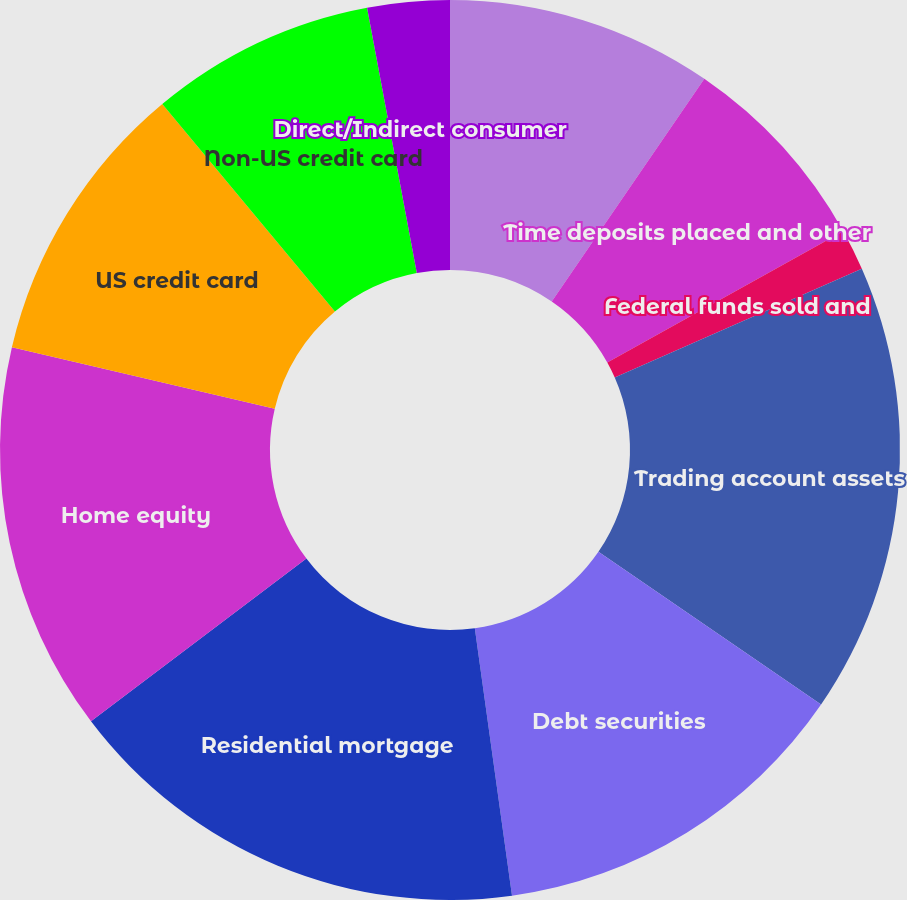Convert chart to OTSL. <chart><loc_0><loc_0><loc_500><loc_500><pie_chart><fcel>Interest-bearing deposits with<fcel>Time deposits placed and other<fcel>Federal funds sold and<fcel>Trading account assets<fcel>Debt securities<fcel>Residential mortgage<fcel>Home equity<fcel>US credit card<fcel>Non-US credit card<fcel>Direct/Indirect consumer<nl><fcel>9.56%<fcel>7.36%<fcel>1.48%<fcel>16.17%<fcel>13.23%<fcel>16.9%<fcel>13.97%<fcel>10.29%<fcel>8.09%<fcel>2.95%<nl></chart> 